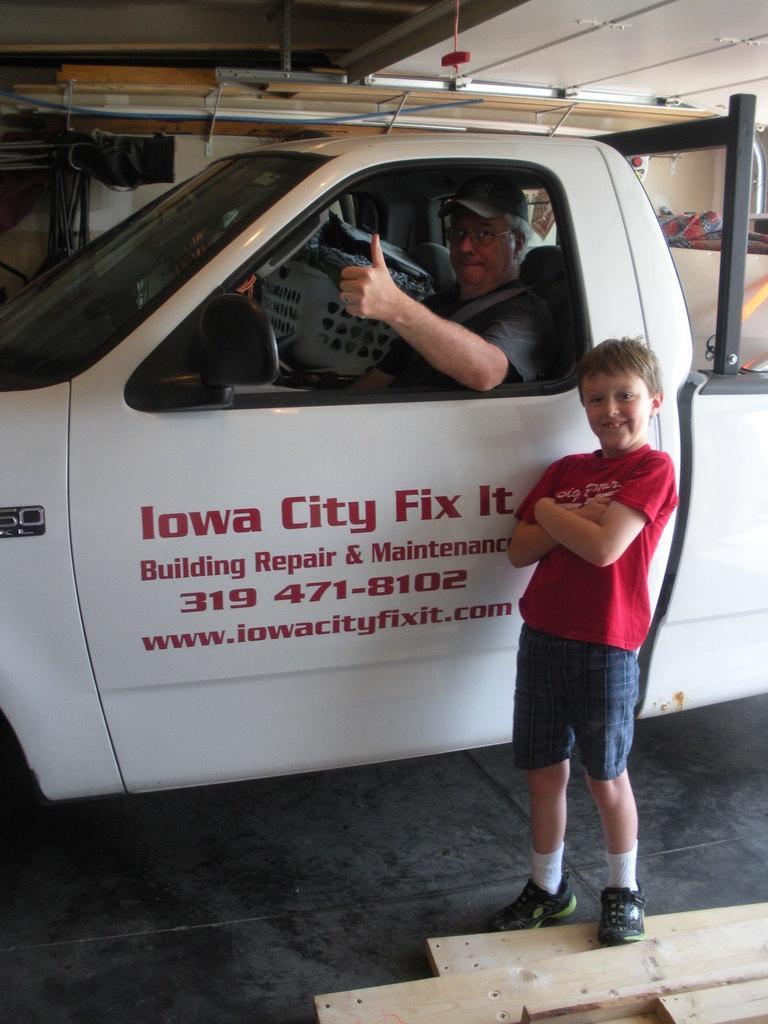Can you describe this image briefly? In this picture we can see a man sitting in a vehicle. We can see a boy wearing red t-shirt, standing near to a car. 